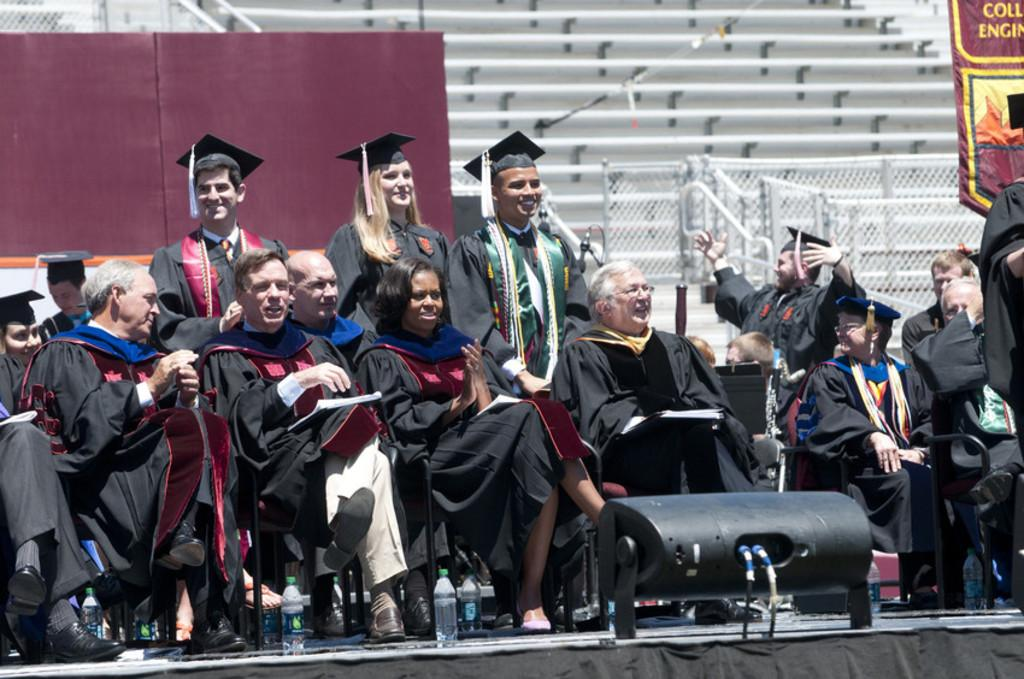How many people are in the image? There is a group of people in the image. What are the people doing in the image? Some people are sitting, while others are standing. What color are the dresses worn by the people in the image? The people are wearing black-colored dresses. What can be seen in the background of the image? There is a board and stairs visible in the background of the image. What is the color of the board in the background? The board is maroon-colored. What type of fiction is being discussed by the people in the image? There is no indication in the image that the people are discussing fiction. Can you tell me the haircut of the person standing on the stairs? There is no information about the haircuts of the people in the image. 